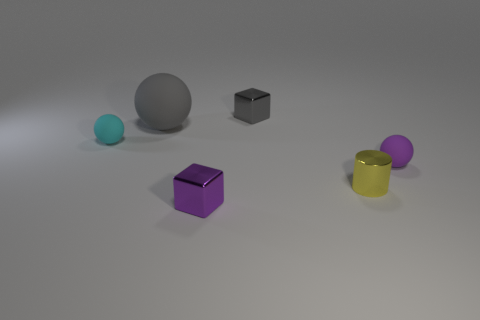Subtract all purple spheres. How many spheres are left? 2 Subtract 1 spheres. How many spheres are left? 2 Add 3 tiny cyan balls. How many objects exist? 9 Subtract 0 green cylinders. How many objects are left? 6 Subtract all cylinders. How many objects are left? 5 Subtract all cyan blocks. Subtract all yellow cylinders. How many blocks are left? 2 Subtract all brown blocks. Subtract all tiny purple things. How many objects are left? 4 Add 2 tiny purple matte objects. How many tiny purple matte objects are left? 3 Add 5 large gray objects. How many large gray objects exist? 6 